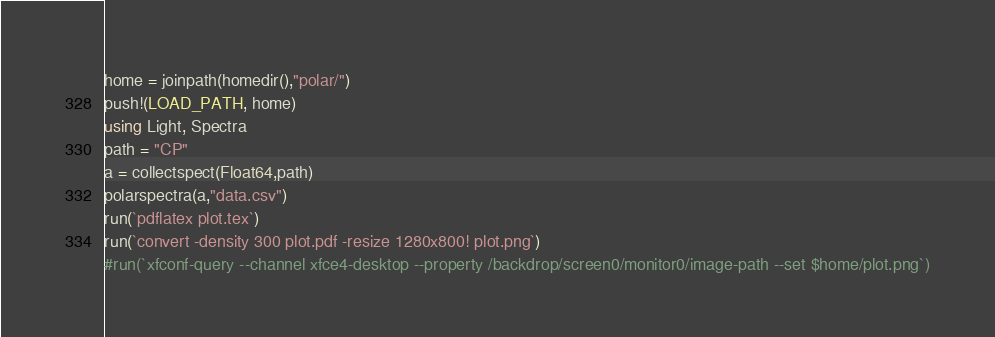Convert code to text. <code><loc_0><loc_0><loc_500><loc_500><_Julia_>home = joinpath(homedir(),"polar/")
push!(LOAD_PATH, home)
using Light, Spectra
path = "CP"
a = collectspect(Float64,path)
polarspectra(a,"data.csv")
run(`pdflatex plot.tex`)
run(`convert -density 300 plot.pdf -resize 1280x800! plot.png`)
#run(`xfconf-query --channel xfce4-desktop --property /backdrop/screen0/monitor0/image-path --set $home/plot.png`)

</code> 